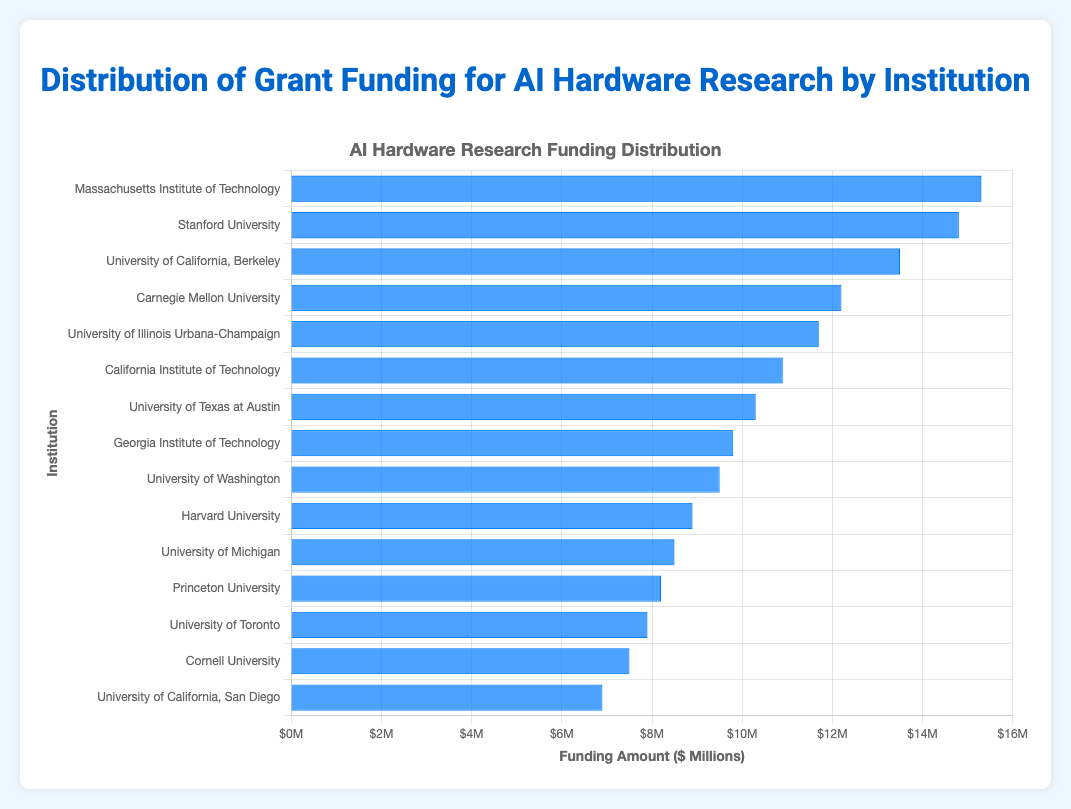Which institution received the highest funding amount? By observing the length of the bars, the longest bar corresponds to the Massachusetts Institute of Technology, which received $15.3M.
Answer: Massachusetts Institute of Technology How much more funding did Stanford University receive compared to Harvard University? Stanford University received $14.8M and Harvard University received $8.9M. The difference is $14.8M - $8.9M = $5.9M.
Answer: $5.9M What is the average funding amount given to all institutions? Sum all the funding amounts: $15.3M + $14.8M + $13.5M + $12.2M + $11.7M + $10.9M + $10.3M + $9.8M + $9.5M + $8.9M + $8.5M + $8.2M + $7.9M + $7.5M + $6.9M = $156.8M. There are 15 institutions, so the average funding amount is $156.8M / 15 ≈ $10.45M.
Answer: $10.45M What is the total funding amount received by institutions from the University of California system? Adding funding for University of California campuses: Berkeley ($13.5M) + San Diego ($6.9M) = $13.5M + $6.9M = $20.4M.
Answer: $20.4M Which three institutions received the least funding? The shortest bars represent Cornell University ($7.5M), University of California, San Diego ($6.9M), and University of Toronto ($7.9M).
Answer: Cornell University, University of California, San Diego, University of Toronto Is the funding amount for Carnegie Mellon University greater than that for the University of Washington? Carnegie Mellon University received $12.2M while the University of Washington received $9.5M. Since $12.2M > $9.5M, yes, it is greater.
Answer: Yes What is the range of the funding amounts? The highest funding amount is $15.3M and the lowest is $6.9M. The range is $15.3M - $6.9M = $8.4M.
Answer: $8.4M Which funding amount is closer to the middle value, Georgia Institute of Technology's or Princeton University's? The funding amounts for Georgia Institute of Technology and Princeton University are $9.8M and $8.2M, respectively. The average funding (middle value) is approximately $10.45M. $9.8M is closer to $10.45M than $8.2M is.
Answer: Georgia Institute of Technology 